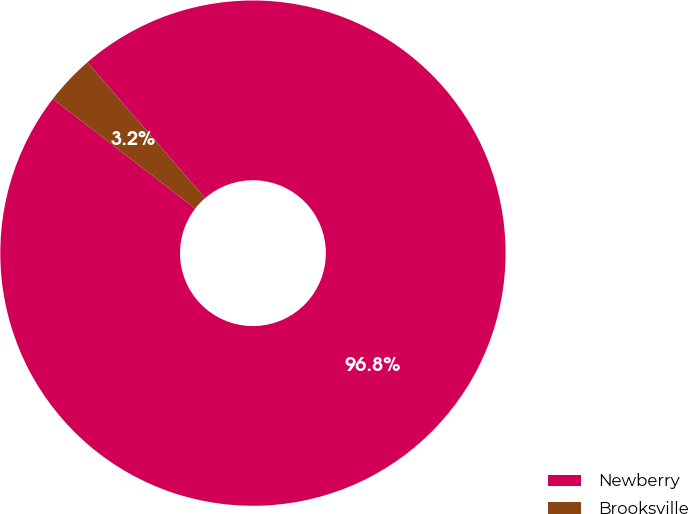Convert chart. <chart><loc_0><loc_0><loc_500><loc_500><pie_chart><fcel>Newberry<fcel>Brooksville<nl><fcel>96.83%<fcel>3.17%<nl></chart> 